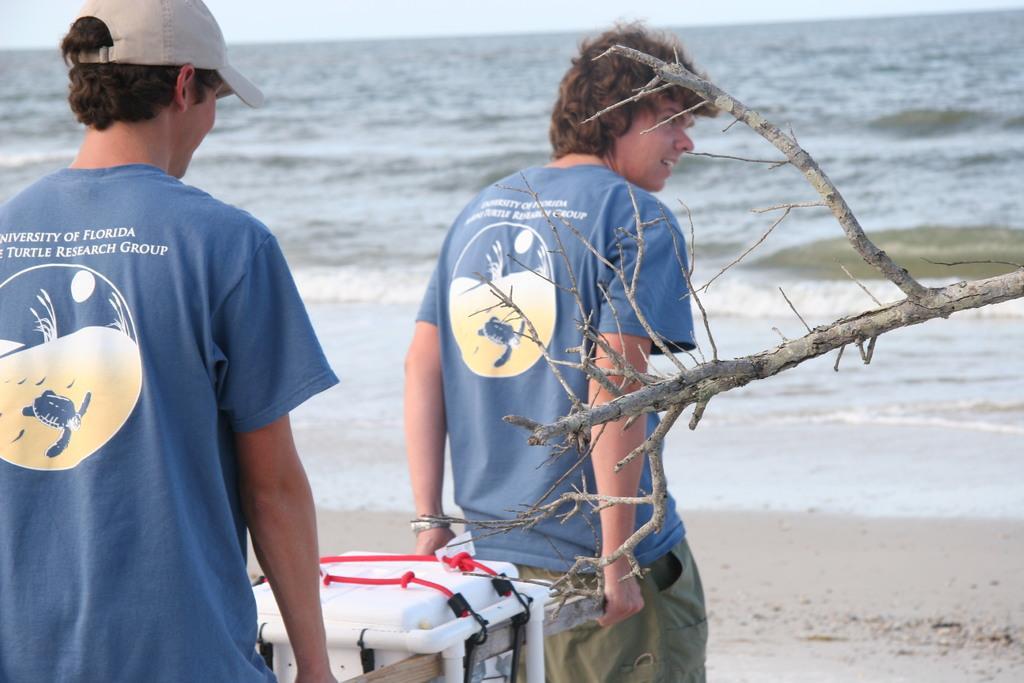How would you summarize this image in a sentence or two? In this picture there are two boys on the left side of the image, by holding a box and there is water at the top side of the image. 